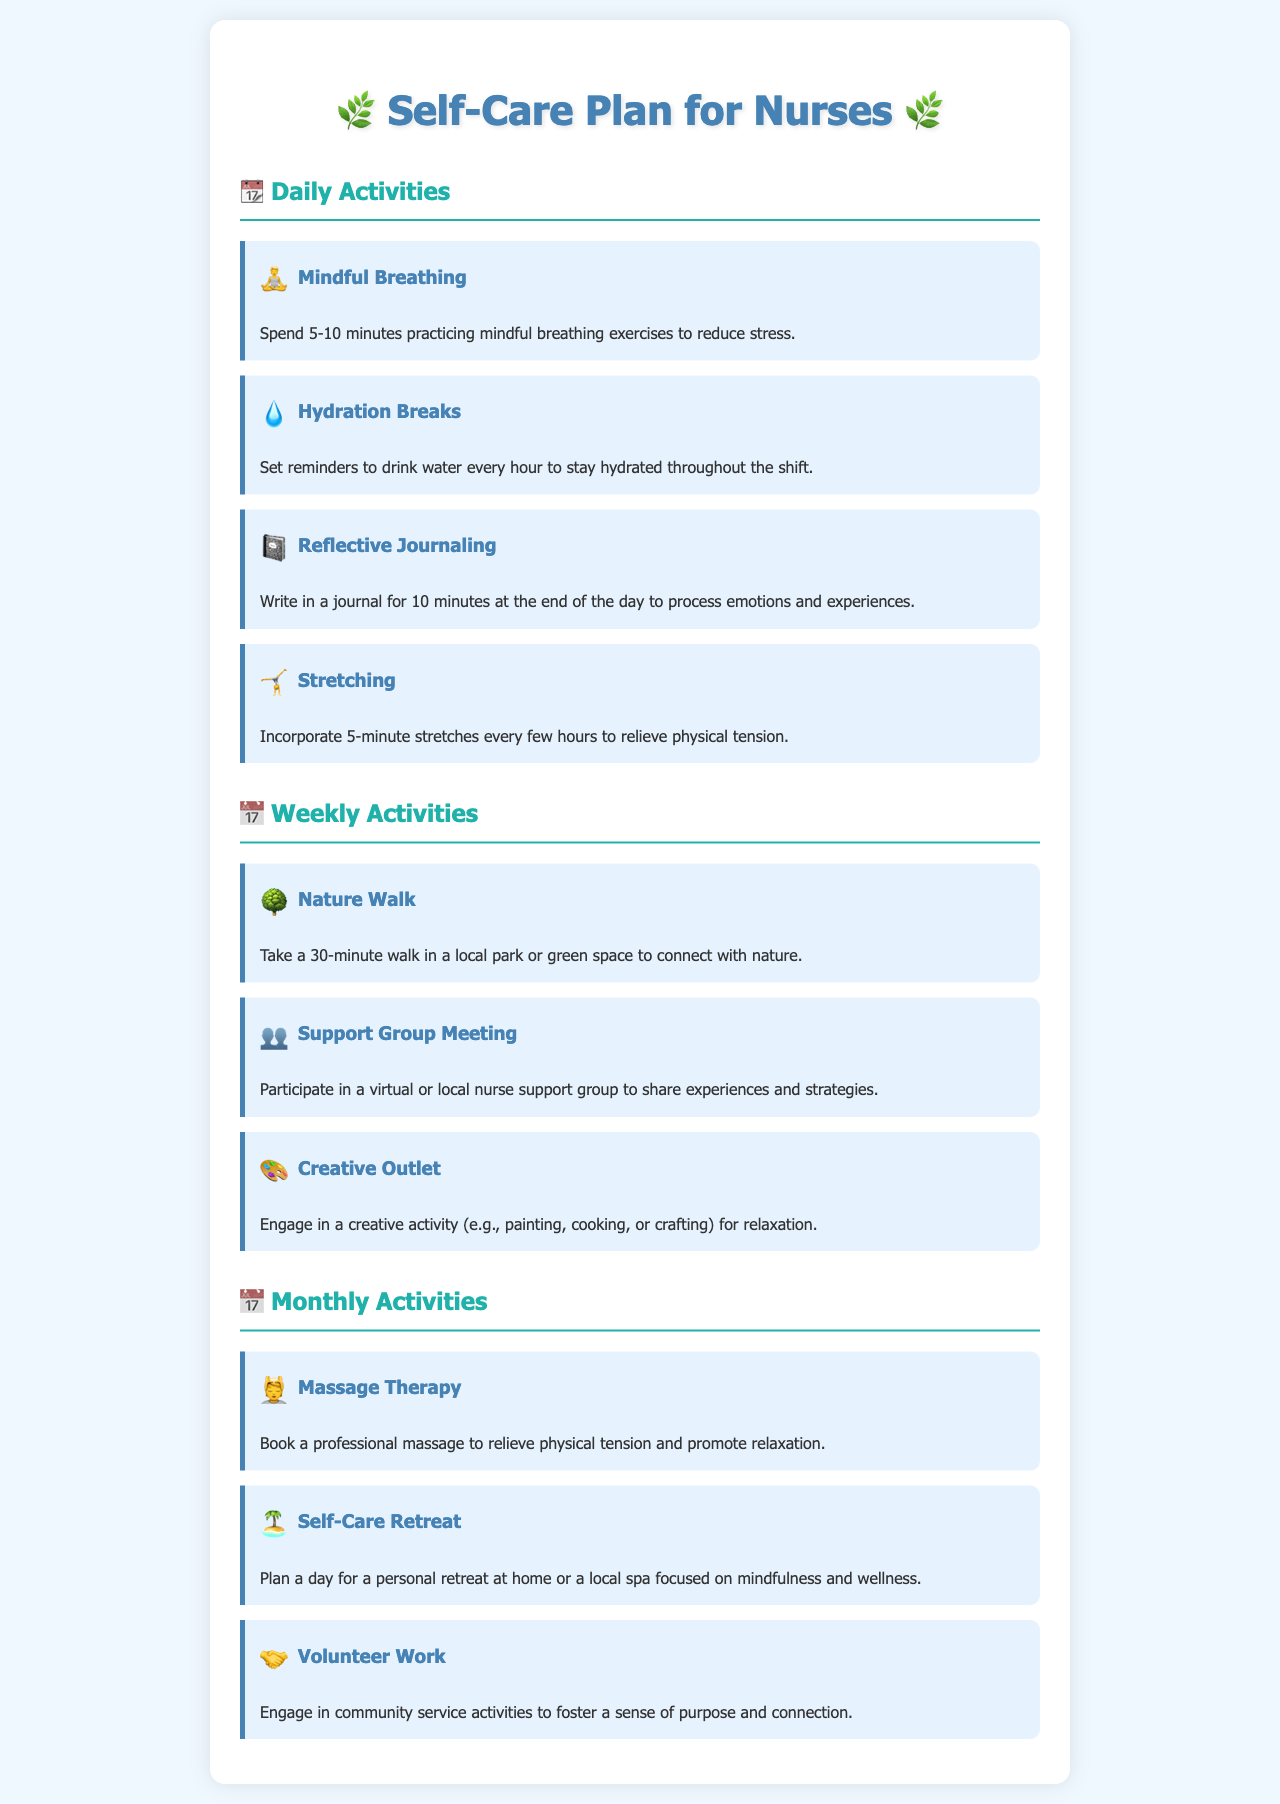what are daily activities listed? The document provides daily activities aimed at promoting well-being, which include mindful breathing, hydration breaks, reflective journaling, and stretching.
Answer: mindful breathing, hydration breaks, reflective journaling, stretching how long should mindfulness exercises last? The document specifies that mindfulness exercises should be practiced for 5-10 minutes.
Answer: 5-10 minutes what is one of the weekly activities? The document lists several weekly activities, including a nature walk, which is aimed at connecting with nature.
Answer: nature walk how many minutes is a nature walk suggested to be? The document states that a nature walk should last for 30 minutes.
Answer: 30 minutes what type of therapy is recommended monthly? The document suggests engaging in massage therapy as a monthly activity for physical relief.
Answer: massage therapy what is an example of a creative outlet activity? The document mentions engaging in activities like painting, cooking, or crafting as a creative outlet.
Answer: painting, cooking, or crafting which category includes support group meetings? Support group meetings are categorized as weekly activities for nurses to share their experiences.
Answer: weekly activities how often should nurses participate in volunteer work? The document states that engaging in volunteer work is recommended as a monthly activity.
Answer: monthly activity 